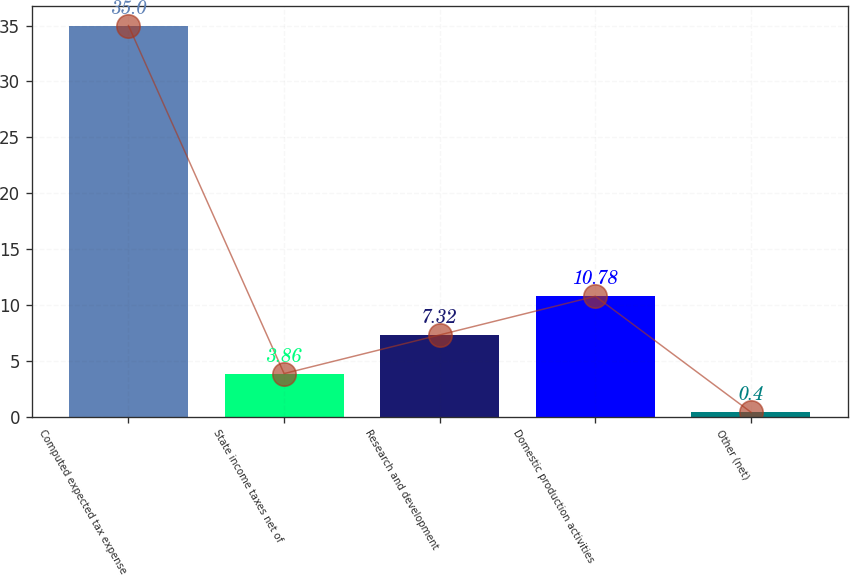<chart> <loc_0><loc_0><loc_500><loc_500><bar_chart><fcel>Computed expected tax expense<fcel>State income taxes net of<fcel>Research and development<fcel>Domestic production activities<fcel>Other (net)<nl><fcel>35<fcel>3.86<fcel>7.32<fcel>10.78<fcel>0.4<nl></chart> 